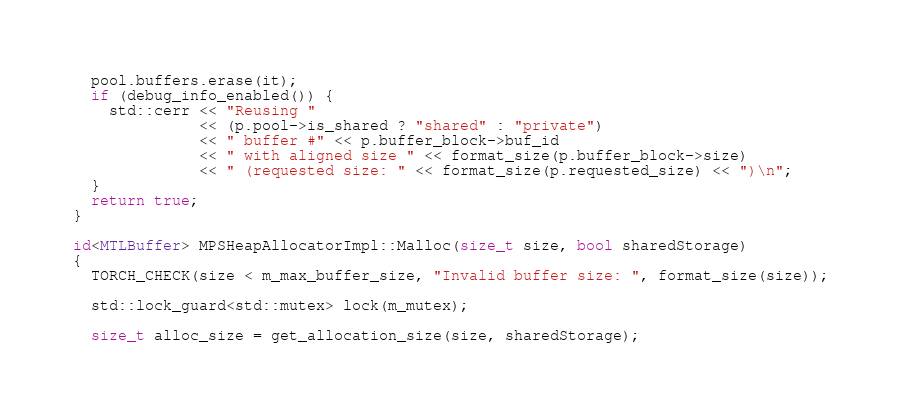Convert code to text. <code><loc_0><loc_0><loc_500><loc_500><_ObjectiveC_>  pool.buffers.erase(it);
  if (debug_info_enabled()) {
    std::cerr << "Reusing "
              << (p.pool->is_shared ? "shared" : "private")
              << " buffer #" << p.buffer_block->buf_id
              << " with aligned size " << format_size(p.buffer_block->size)
              << " (requested size: " << format_size(p.requested_size) << ")\n";
  }
  return true;
}

id<MTLBuffer> MPSHeapAllocatorImpl::Malloc(size_t size, bool sharedStorage)
{
  TORCH_CHECK(size < m_max_buffer_size, "Invalid buffer size: ", format_size(size));

  std::lock_guard<std::mutex> lock(m_mutex);

  size_t alloc_size = get_allocation_size(size, sharedStorage);</code> 